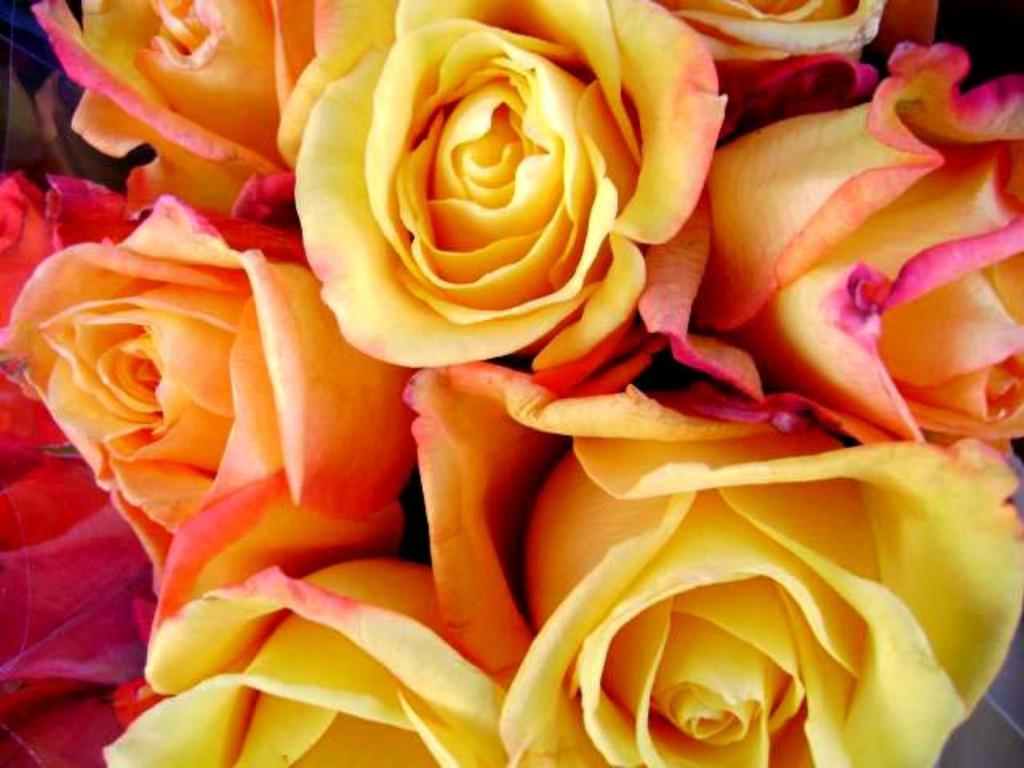What type of living organisms can be seen in the image? Flowers are visible in the image. What type of fruit can be seen in the image? There is no fruit present in the image; it only contains flowers. Can you hear the flowers in the image? The image is visual, so there is no sound or hearing involved. 